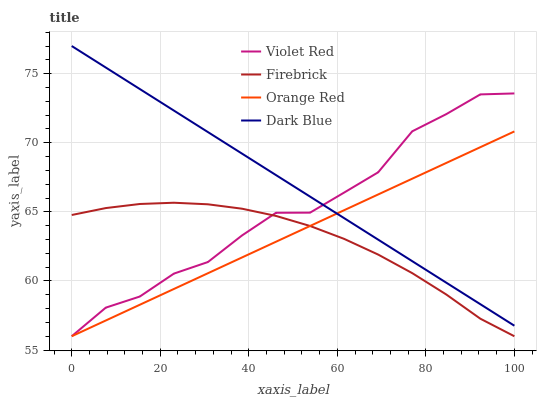Does Firebrick have the minimum area under the curve?
Answer yes or no. Yes. Does Dark Blue have the maximum area under the curve?
Answer yes or no. Yes. Does Violet Red have the minimum area under the curve?
Answer yes or no. No. Does Violet Red have the maximum area under the curve?
Answer yes or no. No. Is Orange Red the smoothest?
Answer yes or no. Yes. Is Violet Red the roughest?
Answer yes or no. Yes. Is Firebrick the smoothest?
Answer yes or no. No. Is Firebrick the roughest?
Answer yes or no. No. Does Violet Red have the lowest value?
Answer yes or no. Yes. Does Dark Blue have the highest value?
Answer yes or no. Yes. Does Violet Red have the highest value?
Answer yes or no. No. Is Firebrick less than Dark Blue?
Answer yes or no. Yes. Is Dark Blue greater than Firebrick?
Answer yes or no. Yes. Does Dark Blue intersect Orange Red?
Answer yes or no. Yes. Is Dark Blue less than Orange Red?
Answer yes or no. No. Is Dark Blue greater than Orange Red?
Answer yes or no. No. Does Firebrick intersect Dark Blue?
Answer yes or no. No. 